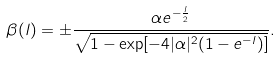<formula> <loc_0><loc_0><loc_500><loc_500>\beta ( l ) = \pm \frac { \alpha e ^ { - \frac { l } { 2 } } } { \sqrt { 1 - \exp [ - 4 | \alpha | ^ { 2 } ( 1 - e ^ { - l } ) ] } } .</formula> 